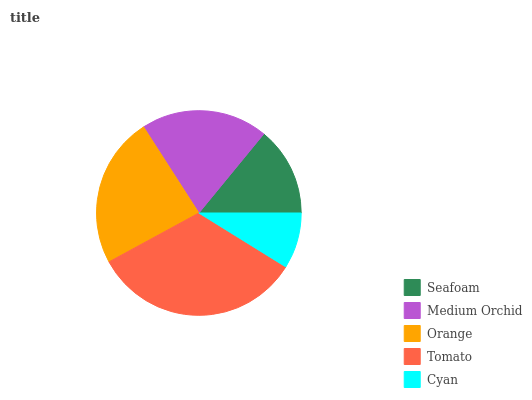Is Cyan the minimum?
Answer yes or no. Yes. Is Tomato the maximum?
Answer yes or no. Yes. Is Medium Orchid the minimum?
Answer yes or no. No. Is Medium Orchid the maximum?
Answer yes or no. No. Is Medium Orchid greater than Seafoam?
Answer yes or no. Yes. Is Seafoam less than Medium Orchid?
Answer yes or no. Yes. Is Seafoam greater than Medium Orchid?
Answer yes or no. No. Is Medium Orchid less than Seafoam?
Answer yes or no. No. Is Medium Orchid the high median?
Answer yes or no. Yes. Is Medium Orchid the low median?
Answer yes or no. Yes. Is Seafoam the high median?
Answer yes or no. No. Is Tomato the low median?
Answer yes or no. No. 